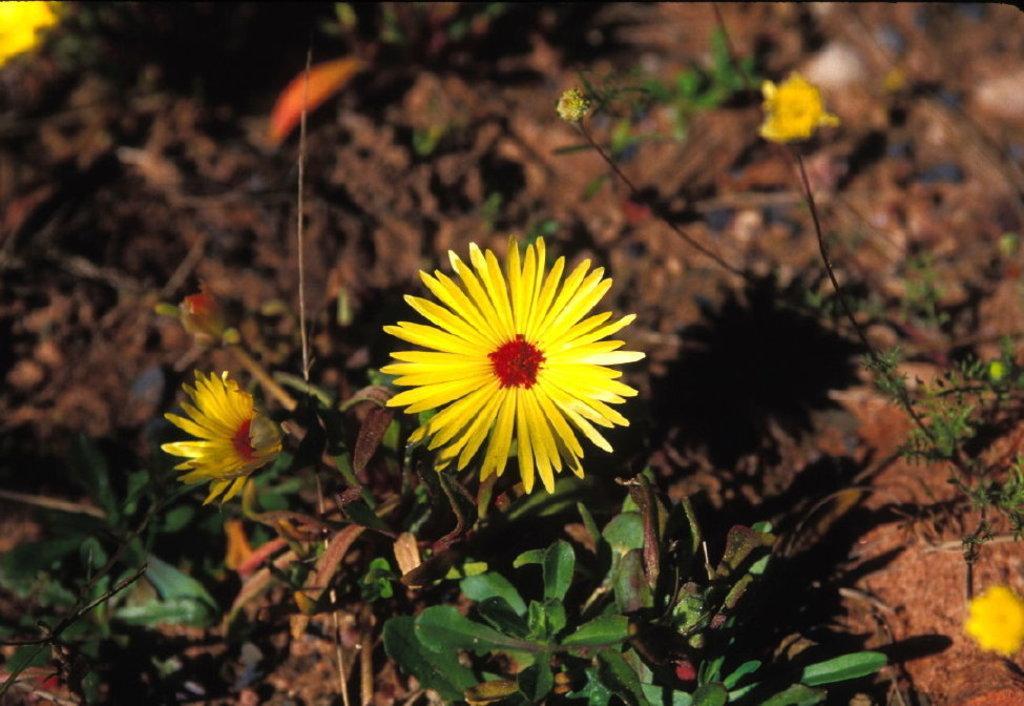How would you summarize this image in a sentence or two? There are plants, which are having yellow color flowers on the ground, on which, there are some objects. 